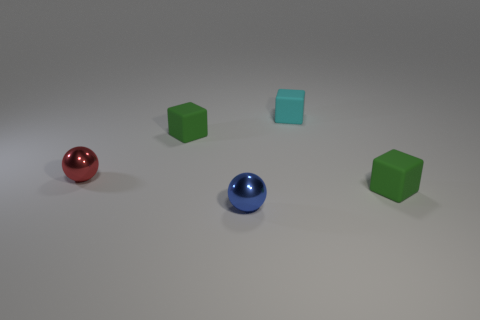What is the color of the other small thing that is the same material as the tiny blue thing?
Your answer should be compact. Red. What color is the shiny ball in front of the small green matte cube that is in front of the shiny sphere that is to the left of the tiny blue metal thing?
Ensure brevity in your answer.  Blue. What number of blocks are either small green things or small cyan things?
Ensure brevity in your answer.  3. What number of things are tiny red metallic things or metallic cylinders?
Your answer should be compact. 1. What is the material of the cyan object that is the same size as the red thing?
Your response must be concise. Rubber. There is a green matte cube that is behind the red thing; how big is it?
Your answer should be compact. Small. What material is the cyan object?
Keep it short and to the point. Rubber. How many things are either small rubber objects left of the blue metal object or tiny green matte cubes that are on the left side of the tiny blue thing?
Provide a succinct answer. 1. There is a red metal object; does it have the same shape as the tiny green matte thing that is to the right of the blue object?
Your answer should be very brief. No. Are there fewer tiny cyan rubber blocks that are to the left of the tiny blue object than green blocks behind the red metallic ball?
Offer a very short reply. Yes. 